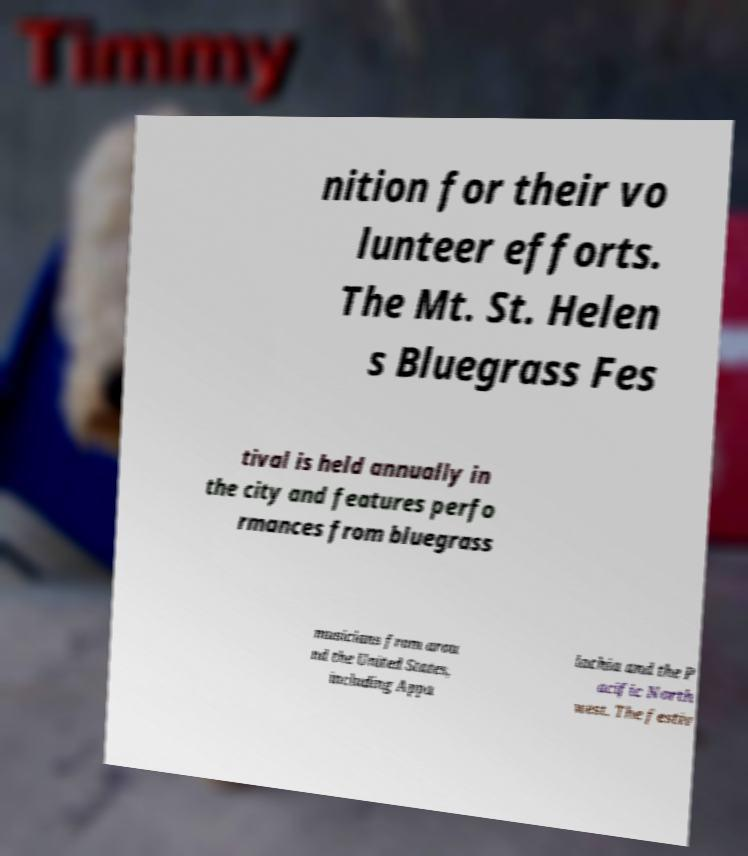There's text embedded in this image that I need extracted. Can you transcribe it verbatim? nition for their vo lunteer efforts. The Mt. St. Helen s Bluegrass Fes tival is held annually in the city and features perfo rmances from bluegrass musicians from arou nd the United States, including Appa lachia and the P acific North west. The festiv 